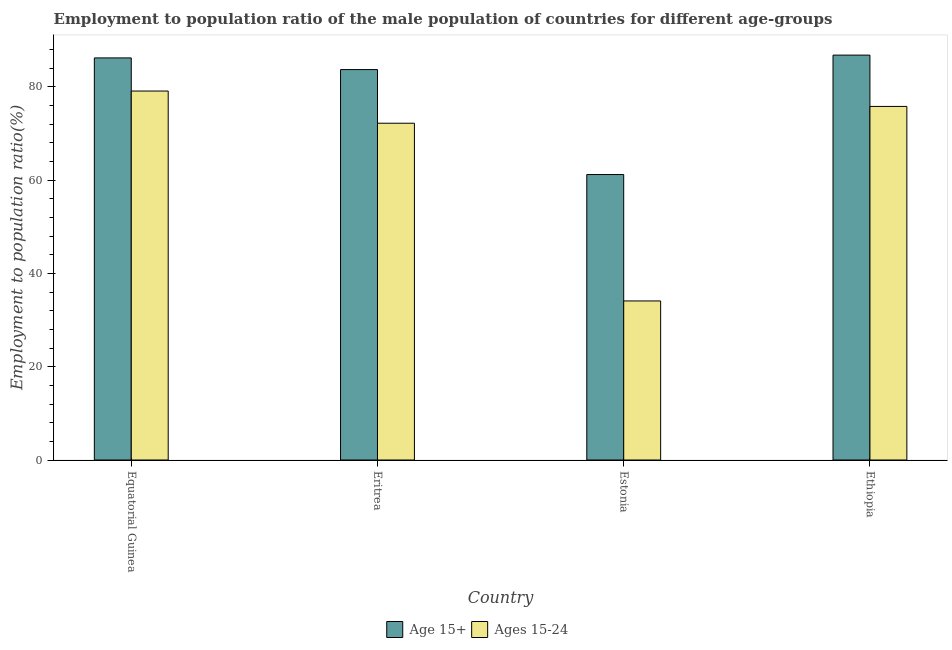How many different coloured bars are there?
Provide a short and direct response. 2. How many groups of bars are there?
Your response must be concise. 4. Are the number of bars per tick equal to the number of legend labels?
Your answer should be compact. Yes. What is the label of the 2nd group of bars from the left?
Your answer should be compact. Eritrea. What is the employment to population ratio(age 15-24) in Ethiopia?
Make the answer very short. 75.8. Across all countries, what is the maximum employment to population ratio(age 15-24)?
Give a very brief answer. 79.1. Across all countries, what is the minimum employment to population ratio(age 15+)?
Provide a succinct answer. 61.2. In which country was the employment to population ratio(age 15+) maximum?
Ensure brevity in your answer.  Ethiopia. In which country was the employment to population ratio(age 15-24) minimum?
Make the answer very short. Estonia. What is the total employment to population ratio(age 15-24) in the graph?
Your answer should be very brief. 261.2. What is the difference between the employment to population ratio(age 15-24) in Eritrea and that in Ethiopia?
Keep it short and to the point. -3.6. What is the difference between the employment to population ratio(age 15+) in Estonia and the employment to population ratio(age 15-24) in Ethiopia?
Make the answer very short. -14.6. What is the average employment to population ratio(age 15+) per country?
Your answer should be compact. 79.47. What is the difference between the employment to population ratio(age 15-24) and employment to population ratio(age 15+) in Eritrea?
Your response must be concise. -11.5. What is the ratio of the employment to population ratio(age 15+) in Estonia to that in Ethiopia?
Your answer should be very brief. 0.71. Is the difference between the employment to population ratio(age 15-24) in Eritrea and Estonia greater than the difference between the employment to population ratio(age 15+) in Eritrea and Estonia?
Keep it short and to the point. Yes. What is the difference between the highest and the second highest employment to population ratio(age 15-24)?
Provide a succinct answer. 3.3. What is the difference between the highest and the lowest employment to population ratio(age 15-24)?
Your answer should be compact. 45. Is the sum of the employment to population ratio(age 15-24) in Equatorial Guinea and Eritrea greater than the maximum employment to population ratio(age 15+) across all countries?
Keep it short and to the point. Yes. What does the 2nd bar from the left in Equatorial Guinea represents?
Offer a very short reply. Ages 15-24. What does the 2nd bar from the right in Estonia represents?
Give a very brief answer. Age 15+. How many countries are there in the graph?
Offer a very short reply. 4. Does the graph contain grids?
Offer a very short reply. No. Where does the legend appear in the graph?
Ensure brevity in your answer.  Bottom center. How are the legend labels stacked?
Offer a very short reply. Horizontal. What is the title of the graph?
Give a very brief answer. Employment to population ratio of the male population of countries for different age-groups. What is the Employment to population ratio(%) of Age 15+ in Equatorial Guinea?
Your answer should be compact. 86.2. What is the Employment to population ratio(%) of Ages 15-24 in Equatorial Guinea?
Your answer should be compact. 79.1. What is the Employment to population ratio(%) in Age 15+ in Eritrea?
Keep it short and to the point. 83.7. What is the Employment to population ratio(%) in Ages 15-24 in Eritrea?
Provide a succinct answer. 72.2. What is the Employment to population ratio(%) in Age 15+ in Estonia?
Your answer should be compact. 61.2. What is the Employment to population ratio(%) in Ages 15-24 in Estonia?
Offer a terse response. 34.1. What is the Employment to population ratio(%) in Age 15+ in Ethiopia?
Provide a short and direct response. 86.8. What is the Employment to population ratio(%) of Ages 15-24 in Ethiopia?
Your answer should be compact. 75.8. Across all countries, what is the maximum Employment to population ratio(%) in Age 15+?
Your answer should be very brief. 86.8. Across all countries, what is the maximum Employment to population ratio(%) of Ages 15-24?
Offer a terse response. 79.1. Across all countries, what is the minimum Employment to population ratio(%) of Age 15+?
Provide a succinct answer. 61.2. Across all countries, what is the minimum Employment to population ratio(%) in Ages 15-24?
Your answer should be very brief. 34.1. What is the total Employment to population ratio(%) of Age 15+ in the graph?
Offer a terse response. 317.9. What is the total Employment to population ratio(%) of Ages 15-24 in the graph?
Give a very brief answer. 261.2. What is the difference between the Employment to population ratio(%) in Age 15+ in Equatorial Guinea and that in Eritrea?
Keep it short and to the point. 2.5. What is the difference between the Employment to population ratio(%) of Ages 15-24 in Equatorial Guinea and that in Estonia?
Offer a very short reply. 45. What is the difference between the Employment to population ratio(%) in Age 15+ in Equatorial Guinea and that in Ethiopia?
Your answer should be compact. -0.6. What is the difference between the Employment to population ratio(%) in Ages 15-24 in Equatorial Guinea and that in Ethiopia?
Your answer should be compact. 3.3. What is the difference between the Employment to population ratio(%) in Age 15+ in Eritrea and that in Estonia?
Give a very brief answer. 22.5. What is the difference between the Employment to population ratio(%) in Ages 15-24 in Eritrea and that in Estonia?
Keep it short and to the point. 38.1. What is the difference between the Employment to population ratio(%) in Ages 15-24 in Eritrea and that in Ethiopia?
Offer a very short reply. -3.6. What is the difference between the Employment to population ratio(%) of Age 15+ in Estonia and that in Ethiopia?
Give a very brief answer. -25.6. What is the difference between the Employment to population ratio(%) of Ages 15-24 in Estonia and that in Ethiopia?
Provide a short and direct response. -41.7. What is the difference between the Employment to population ratio(%) of Age 15+ in Equatorial Guinea and the Employment to population ratio(%) of Ages 15-24 in Eritrea?
Your response must be concise. 14. What is the difference between the Employment to population ratio(%) in Age 15+ in Equatorial Guinea and the Employment to population ratio(%) in Ages 15-24 in Estonia?
Provide a short and direct response. 52.1. What is the difference between the Employment to population ratio(%) in Age 15+ in Equatorial Guinea and the Employment to population ratio(%) in Ages 15-24 in Ethiopia?
Keep it short and to the point. 10.4. What is the difference between the Employment to population ratio(%) in Age 15+ in Eritrea and the Employment to population ratio(%) in Ages 15-24 in Estonia?
Make the answer very short. 49.6. What is the difference between the Employment to population ratio(%) of Age 15+ in Eritrea and the Employment to population ratio(%) of Ages 15-24 in Ethiopia?
Provide a succinct answer. 7.9. What is the difference between the Employment to population ratio(%) of Age 15+ in Estonia and the Employment to population ratio(%) of Ages 15-24 in Ethiopia?
Provide a short and direct response. -14.6. What is the average Employment to population ratio(%) of Age 15+ per country?
Make the answer very short. 79.47. What is the average Employment to population ratio(%) in Ages 15-24 per country?
Give a very brief answer. 65.3. What is the difference between the Employment to population ratio(%) of Age 15+ and Employment to population ratio(%) of Ages 15-24 in Equatorial Guinea?
Provide a short and direct response. 7.1. What is the difference between the Employment to population ratio(%) in Age 15+ and Employment to population ratio(%) in Ages 15-24 in Estonia?
Your answer should be compact. 27.1. What is the difference between the Employment to population ratio(%) in Age 15+ and Employment to population ratio(%) in Ages 15-24 in Ethiopia?
Ensure brevity in your answer.  11. What is the ratio of the Employment to population ratio(%) in Age 15+ in Equatorial Guinea to that in Eritrea?
Provide a short and direct response. 1.03. What is the ratio of the Employment to population ratio(%) in Ages 15-24 in Equatorial Guinea to that in Eritrea?
Make the answer very short. 1.1. What is the ratio of the Employment to population ratio(%) in Age 15+ in Equatorial Guinea to that in Estonia?
Provide a short and direct response. 1.41. What is the ratio of the Employment to population ratio(%) in Ages 15-24 in Equatorial Guinea to that in Estonia?
Provide a succinct answer. 2.32. What is the ratio of the Employment to population ratio(%) in Ages 15-24 in Equatorial Guinea to that in Ethiopia?
Provide a succinct answer. 1.04. What is the ratio of the Employment to population ratio(%) of Age 15+ in Eritrea to that in Estonia?
Make the answer very short. 1.37. What is the ratio of the Employment to population ratio(%) in Ages 15-24 in Eritrea to that in Estonia?
Provide a succinct answer. 2.12. What is the ratio of the Employment to population ratio(%) of Age 15+ in Eritrea to that in Ethiopia?
Make the answer very short. 0.96. What is the ratio of the Employment to population ratio(%) in Ages 15-24 in Eritrea to that in Ethiopia?
Provide a short and direct response. 0.95. What is the ratio of the Employment to population ratio(%) in Age 15+ in Estonia to that in Ethiopia?
Make the answer very short. 0.71. What is the ratio of the Employment to population ratio(%) of Ages 15-24 in Estonia to that in Ethiopia?
Provide a short and direct response. 0.45. What is the difference between the highest and the lowest Employment to population ratio(%) of Age 15+?
Keep it short and to the point. 25.6. What is the difference between the highest and the lowest Employment to population ratio(%) of Ages 15-24?
Your answer should be very brief. 45. 